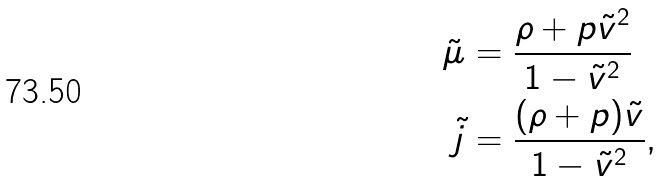<formula> <loc_0><loc_0><loc_500><loc_500>\tilde { \mu } & = \frac { \rho + p \tilde { v } ^ { 2 } } { 1 - \tilde { v } ^ { 2 } } \\ \tilde { j } & = \frac { ( \rho + p ) \tilde { v } } { 1 - \tilde { v } ^ { 2 } } ,</formula> 